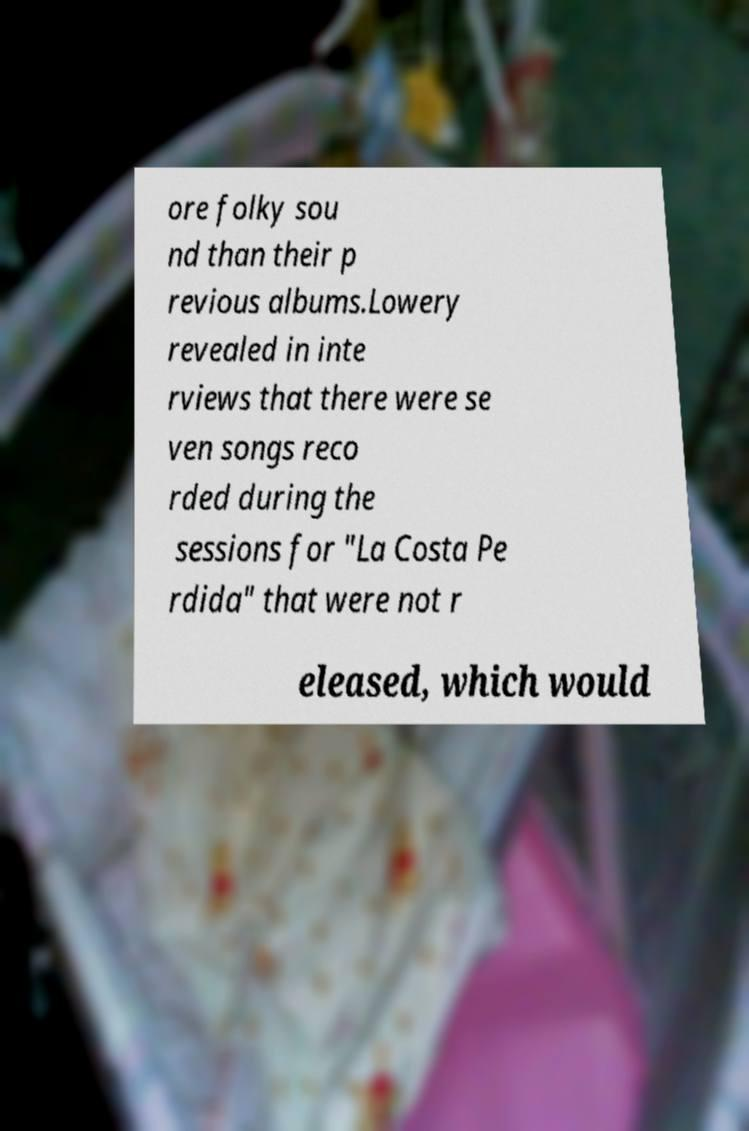Can you read and provide the text displayed in the image?This photo seems to have some interesting text. Can you extract and type it out for me? ore folky sou nd than their p revious albums.Lowery revealed in inte rviews that there were se ven songs reco rded during the sessions for "La Costa Pe rdida" that were not r eleased, which would 